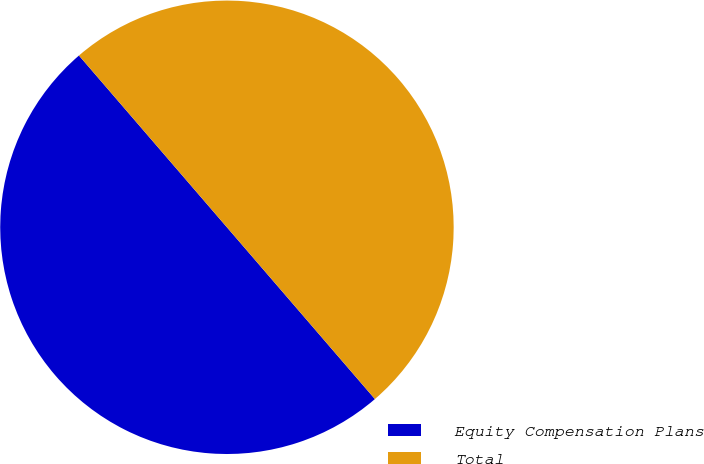Convert chart to OTSL. <chart><loc_0><loc_0><loc_500><loc_500><pie_chart><fcel>Equity Compensation Plans<fcel>Total<nl><fcel>50.0%<fcel>50.0%<nl></chart> 